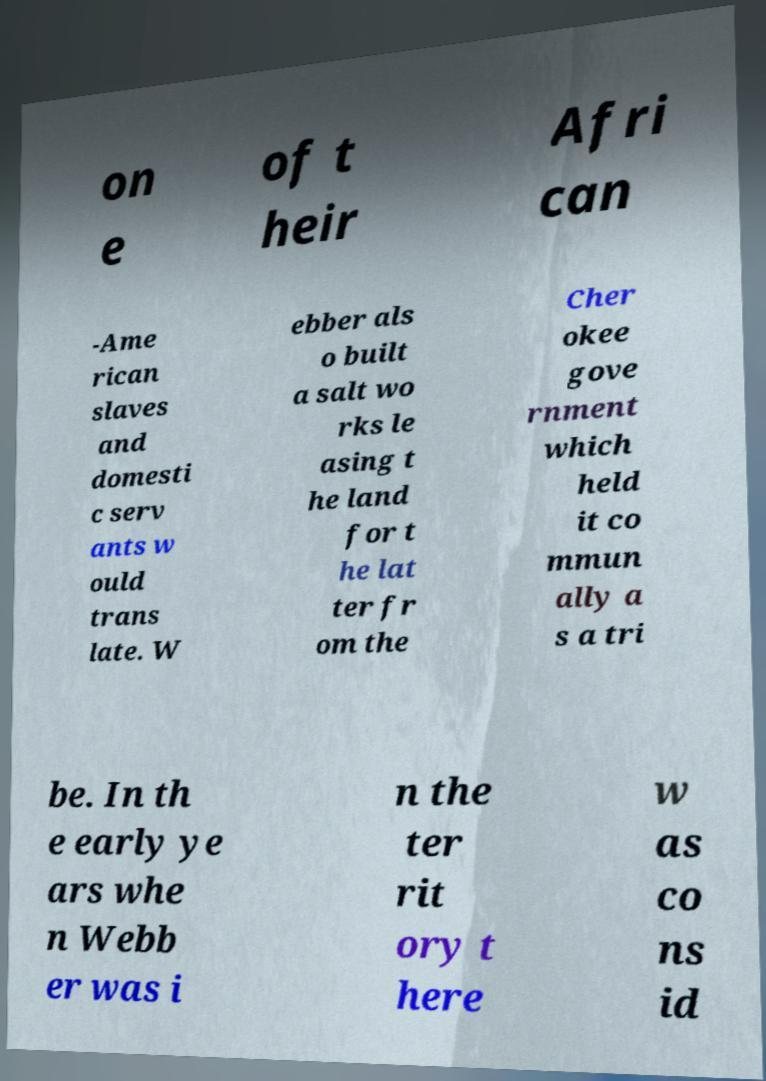Can you read and provide the text displayed in the image?This photo seems to have some interesting text. Can you extract and type it out for me? on e of t heir Afri can -Ame rican slaves and domesti c serv ants w ould trans late. W ebber als o built a salt wo rks le asing t he land for t he lat ter fr om the Cher okee gove rnment which held it co mmun ally a s a tri be. In th e early ye ars whe n Webb er was i n the ter rit ory t here w as co ns id 